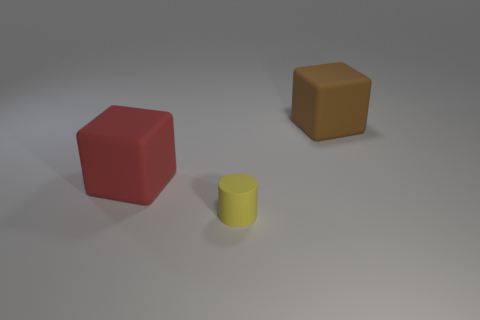The small matte cylinder has what color?
Offer a very short reply. Yellow. There is a matte thing that is both behind the yellow matte thing and on the right side of the big red block; what is its color?
Offer a very short reply. Brown. There is a big matte thing left of the large matte block that is behind the big thing left of the tiny yellow rubber cylinder; what color is it?
Provide a succinct answer. Red. There is another matte object that is the same size as the red rubber object; what is its color?
Give a very brief answer. Brown. What is the shape of the big thing in front of the object that is behind the red matte thing that is to the left of the tiny yellow thing?
Your answer should be compact. Cube. What number of things are large purple matte things or matte blocks that are right of the tiny yellow rubber object?
Offer a very short reply. 1. There is a brown block behind the rubber cylinder; is its size the same as the red cube?
Keep it short and to the point. Yes. What material is the thing that is behind the big red rubber object?
Provide a short and direct response. Rubber. Are there the same number of tiny yellow things that are to the right of the big red block and blocks that are in front of the small yellow cylinder?
Your response must be concise. No. There is another big rubber object that is the same shape as the red thing; what is its color?
Ensure brevity in your answer.  Brown. 